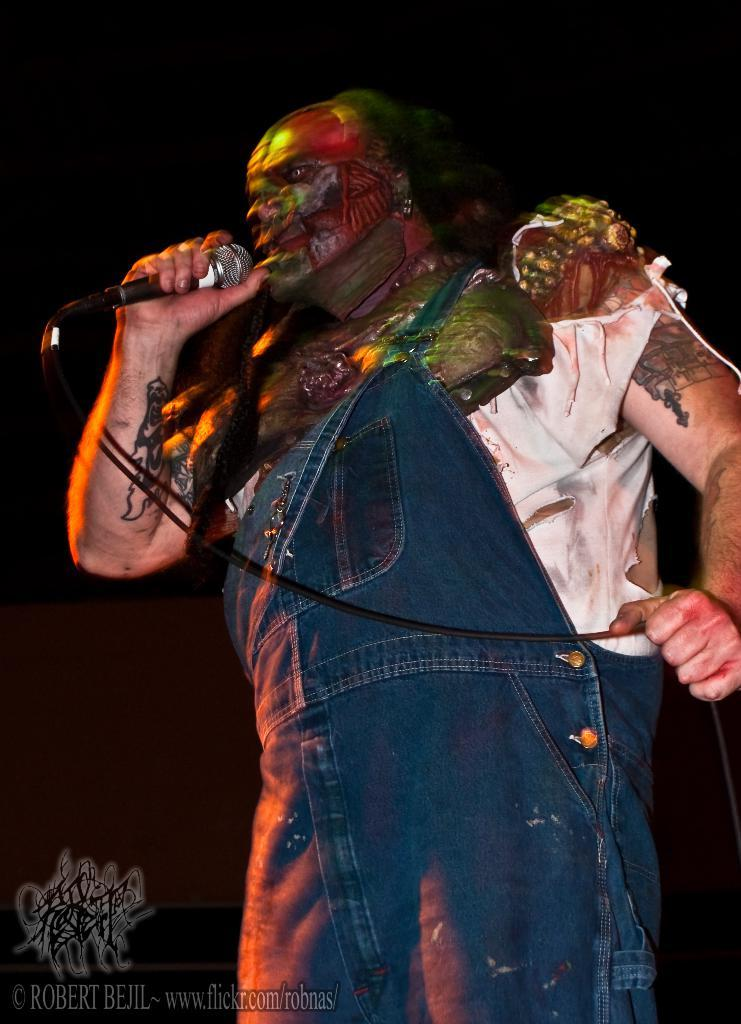What is the person holding in the image? The person is holding a mic in the image. In which direction is the person facing? The person is facing towards the left side of the image. Can you describe any additional elements in the image? There is a watermark at the bottom left side of the image. What type of pump can be seen in the background of the image? There is no pump visible in the background of the image. 